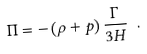Convert formula to latex. <formula><loc_0><loc_0><loc_500><loc_500>\Pi = - \left ( \rho + p \right ) \frac { \Gamma } { 3 H } \ .</formula> 